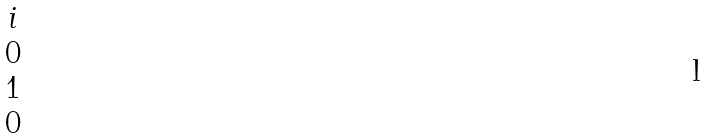Convert formula to latex. <formula><loc_0><loc_0><loc_500><loc_500>\begin{matrix} i \\ 0 \\ 1 \\ 0 \end{matrix}</formula> 